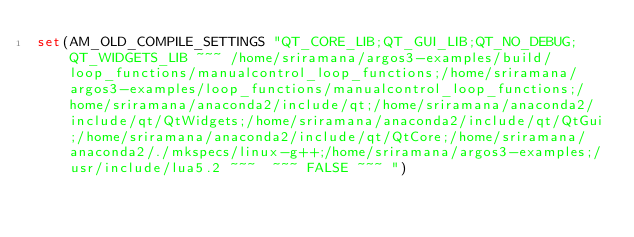Convert code to text. <code><loc_0><loc_0><loc_500><loc_500><_CMake_>set(AM_OLD_COMPILE_SETTINGS "QT_CORE_LIB;QT_GUI_LIB;QT_NO_DEBUG;QT_WIDGETS_LIB ~~~ /home/sriramana/argos3-examples/build/loop_functions/manualcontrol_loop_functions;/home/sriramana/argos3-examples/loop_functions/manualcontrol_loop_functions;/home/sriramana/anaconda2/include/qt;/home/sriramana/anaconda2/include/qt/QtWidgets;/home/sriramana/anaconda2/include/qt/QtGui;/home/sriramana/anaconda2/include/qt/QtCore;/home/sriramana/anaconda2/./mkspecs/linux-g++;/home/sriramana/argos3-examples;/usr/include/lua5.2 ~~~  ~~~ FALSE ~~~ ")
</code> 